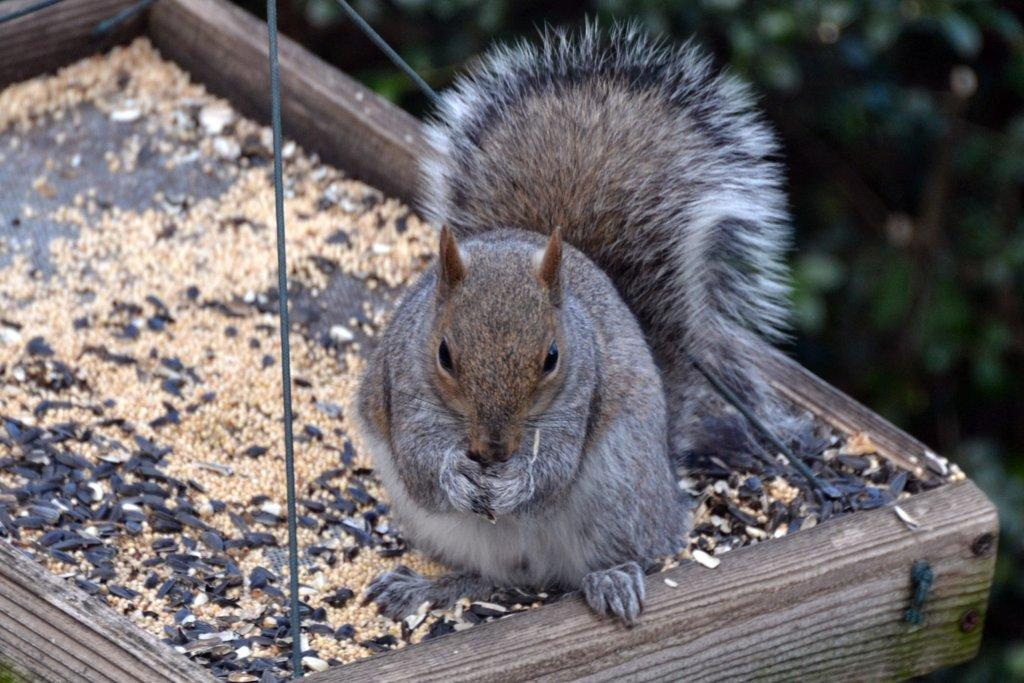What object is located at the bottom of the image? There is a swing at the bottom of the image. What is on the swing in the image? A squirrel is on the swing. Can you describe the background of the image? The background of the image is blurred. How many eggs does the squirrel have in the image? There are no eggs present in the image; it features a squirrel on a swing. What advice does the dad give to the squirrel in the image? There is no dad present in the image, and therefore no advice can be given. 